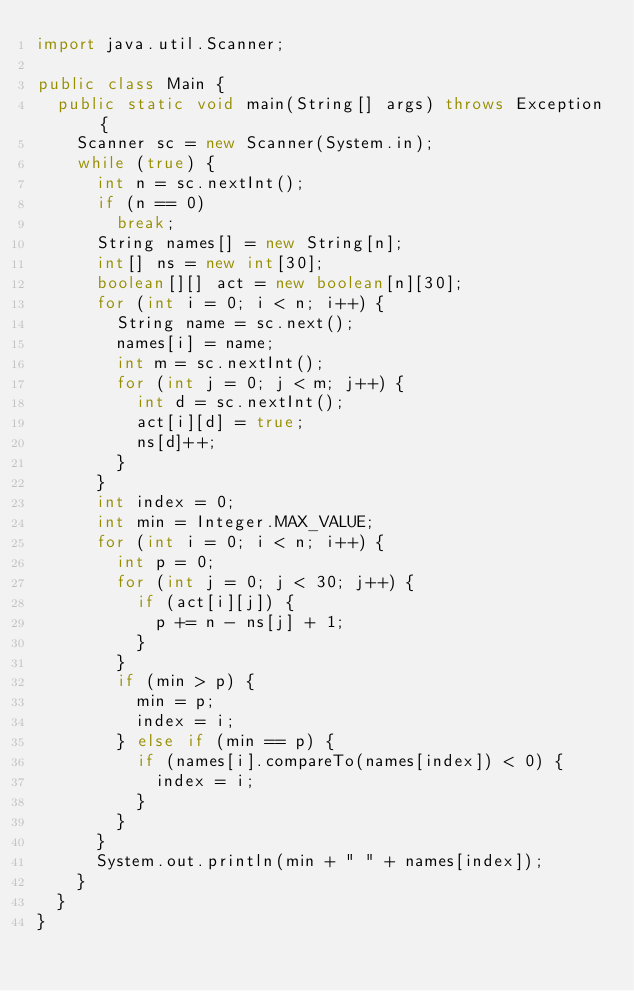<code> <loc_0><loc_0><loc_500><loc_500><_Java_>import java.util.Scanner;

public class Main {
	public static void main(String[] args) throws Exception {
		Scanner sc = new Scanner(System.in);
		while (true) {
			int n = sc.nextInt();
			if (n == 0)
				break;
			String names[] = new String[n];
			int[] ns = new int[30];
			boolean[][] act = new boolean[n][30];
			for (int i = 0; i < n; i++) {
				String name = sc.next();
				names[i] = name;
				int m = sc.nextInt();
				for (int j = 0; j < m; j++) {
					int d = sc.nextInt();
					act[i][d] = true;
					ns[d]++;
				}
			}
			int index = 0;
			int min = Integer.MAX_VALUE;
			for (int i = 0; i < n; i++) {
				int p = 0;
				for (int j = 0; j < 30; j++) {
					if (act[i][j]) {
						p += n - ns[j] + 1;
					}
				}
				if (min > p) {
					min = p;
					index = i;
				} else if (min == p) {
					if (names[i].compareTo(names[index]) < 0) {
						index = i;
					}
				}
			}
			System.out.println(min + " " + names[index]);
		}
	}
}</code> 